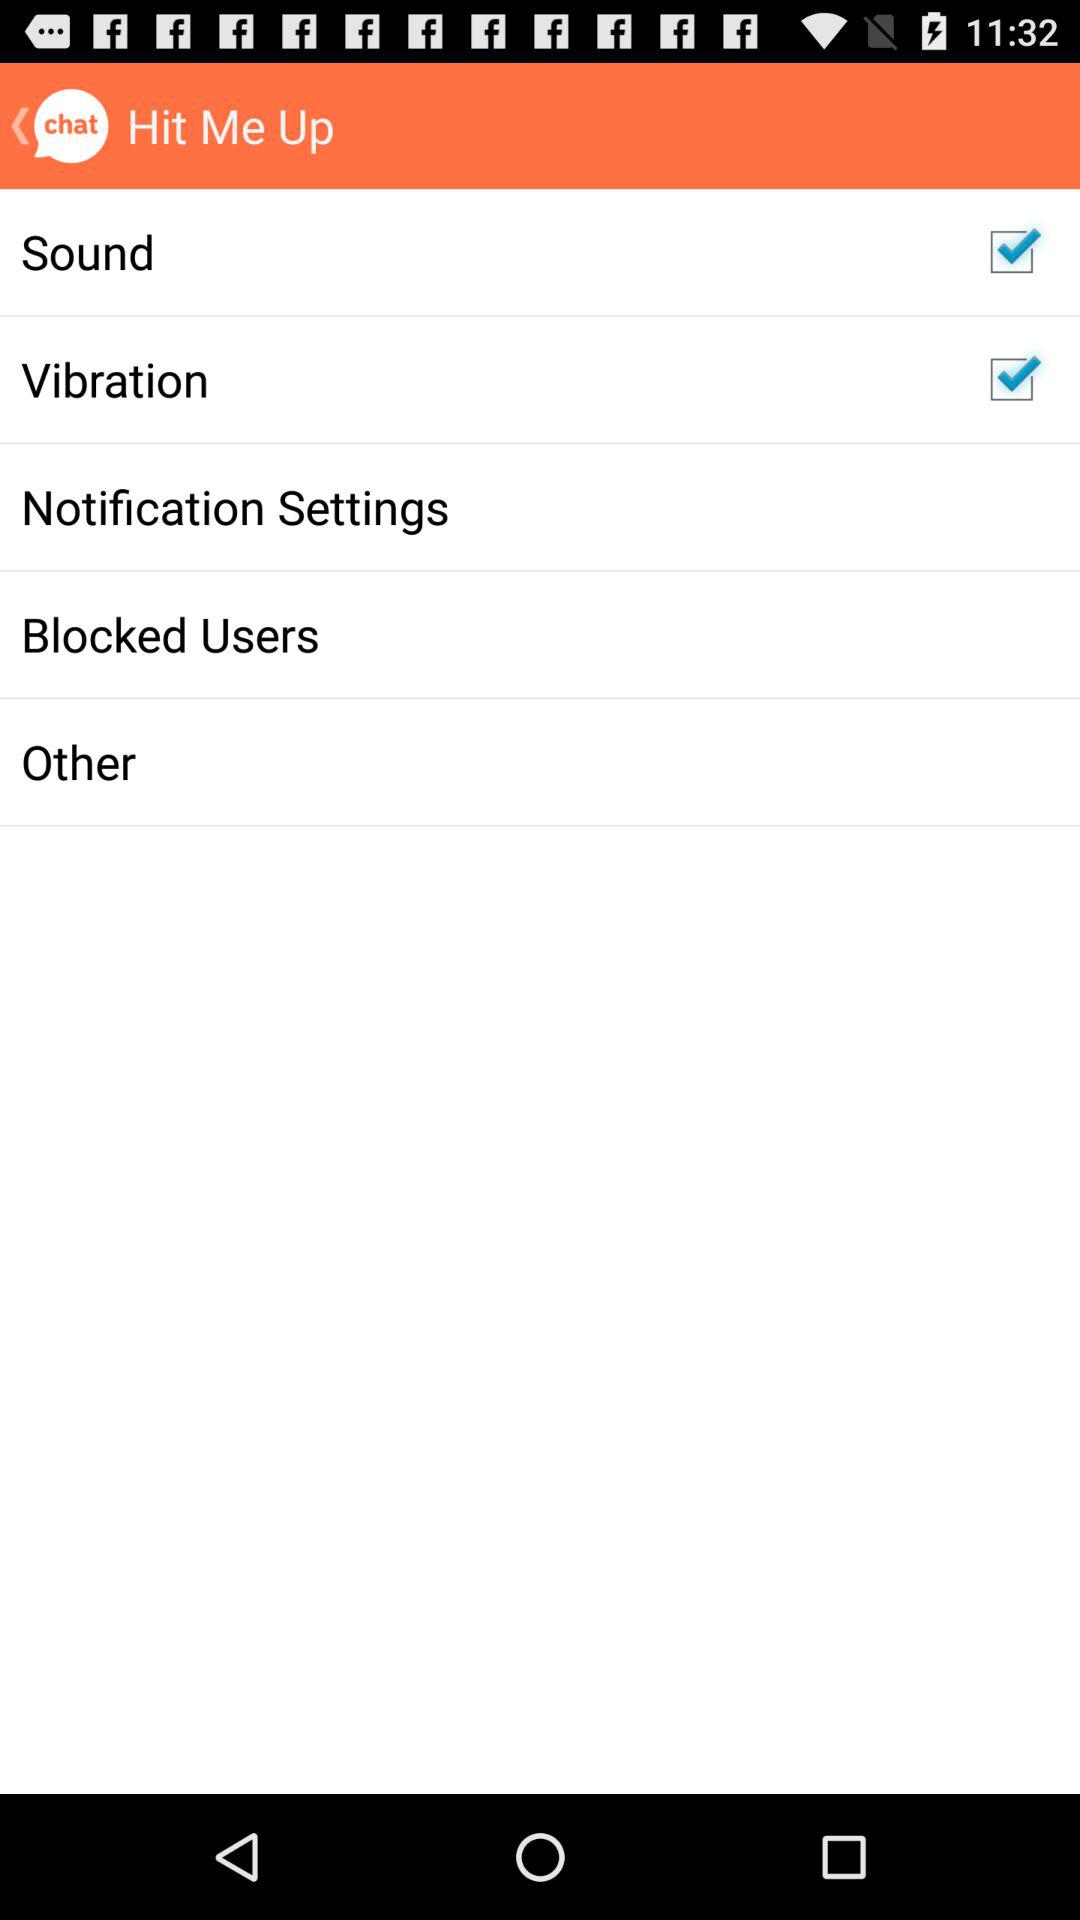What is the current status of "Vibration"? The current status of "Vibration" is "on". 